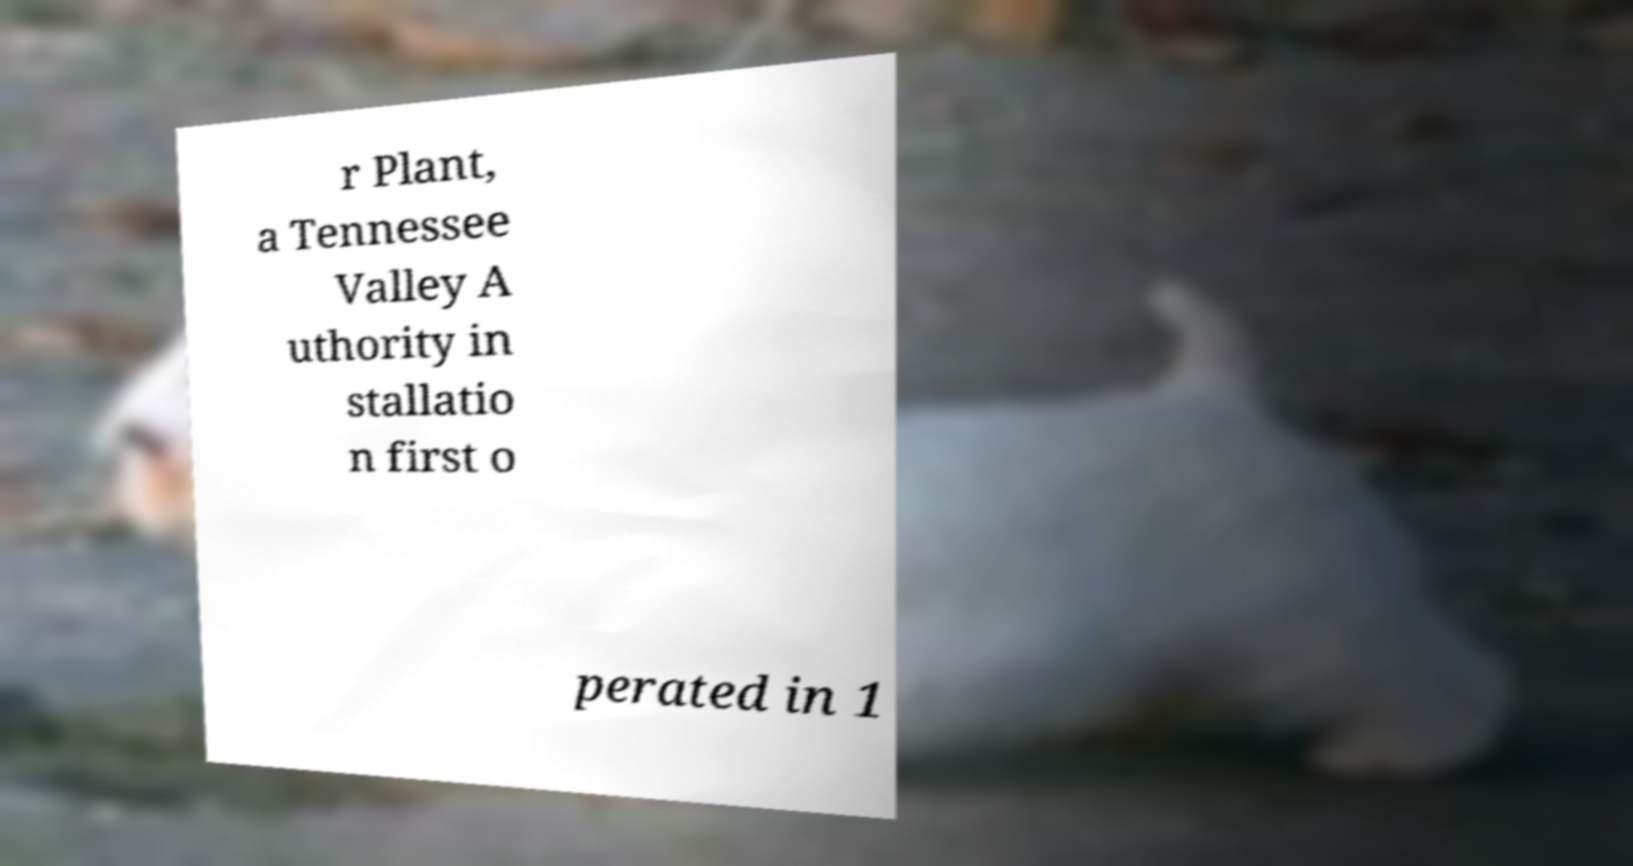I need the written content from this picture converted into text. Can you do that? r Plant, a Tennessee Valley A uthority in stallatio n first o perated in 1 